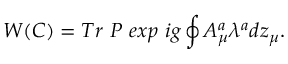<formula> <loc_0><loc_0><loc_500><loc_500>W ( C ) = T r P e x p i g \oint A _ { \mu } ^ { a } \lambda ^ { a } d z _ { \mu } .</formula> 